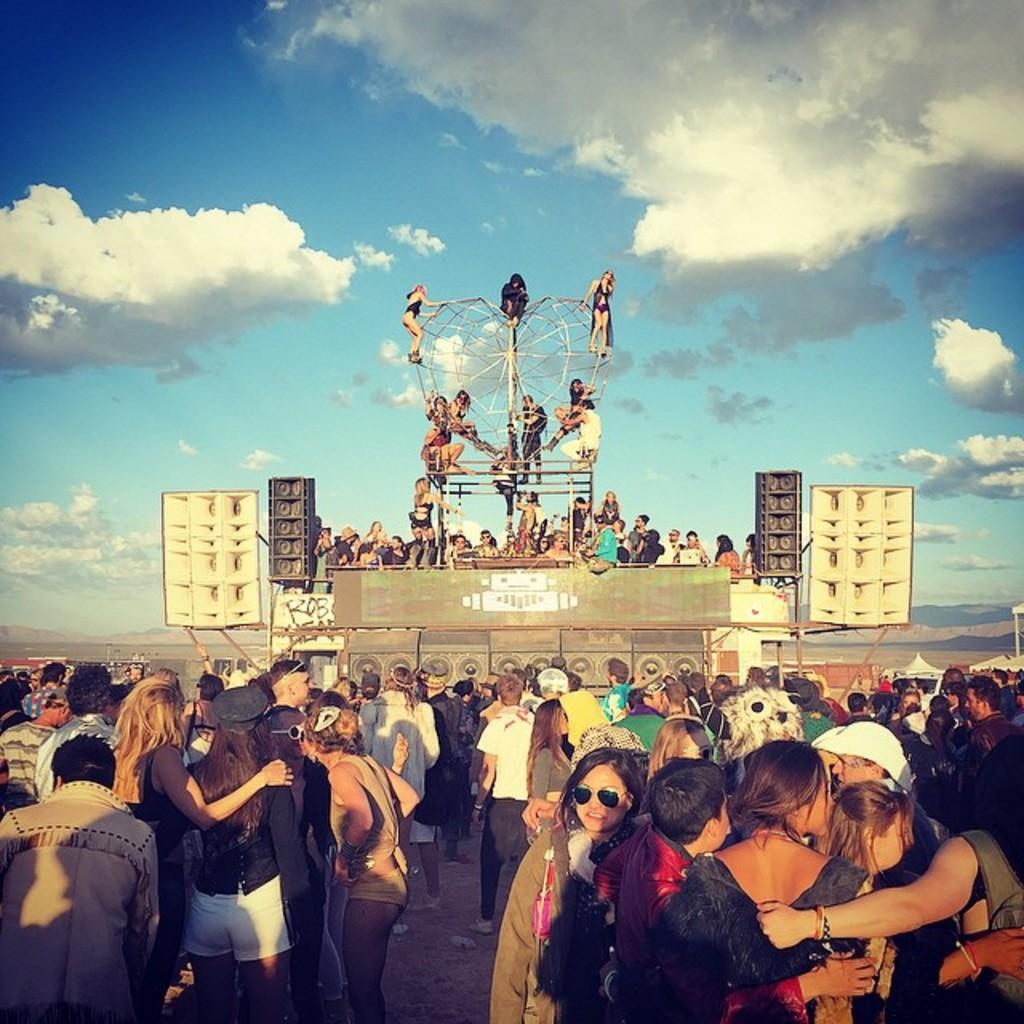Who or what can be seen in the image? There are people in the image. What is the main feature of the image? There is a stage in the image. What equipment is present in the image? There are speakers in the image. What other objects can be seen in the image? There are rods in the image. What can be seen in the background of the image? The sky is visible in the background of the image, and there are clouds in the sky. Can you see a crown on the head of any person in the image? There is no crown visible on the head of any person in the image. What type of angle is being used to capture the image? The angle used to capture the image cannot be determined from the image itself. 